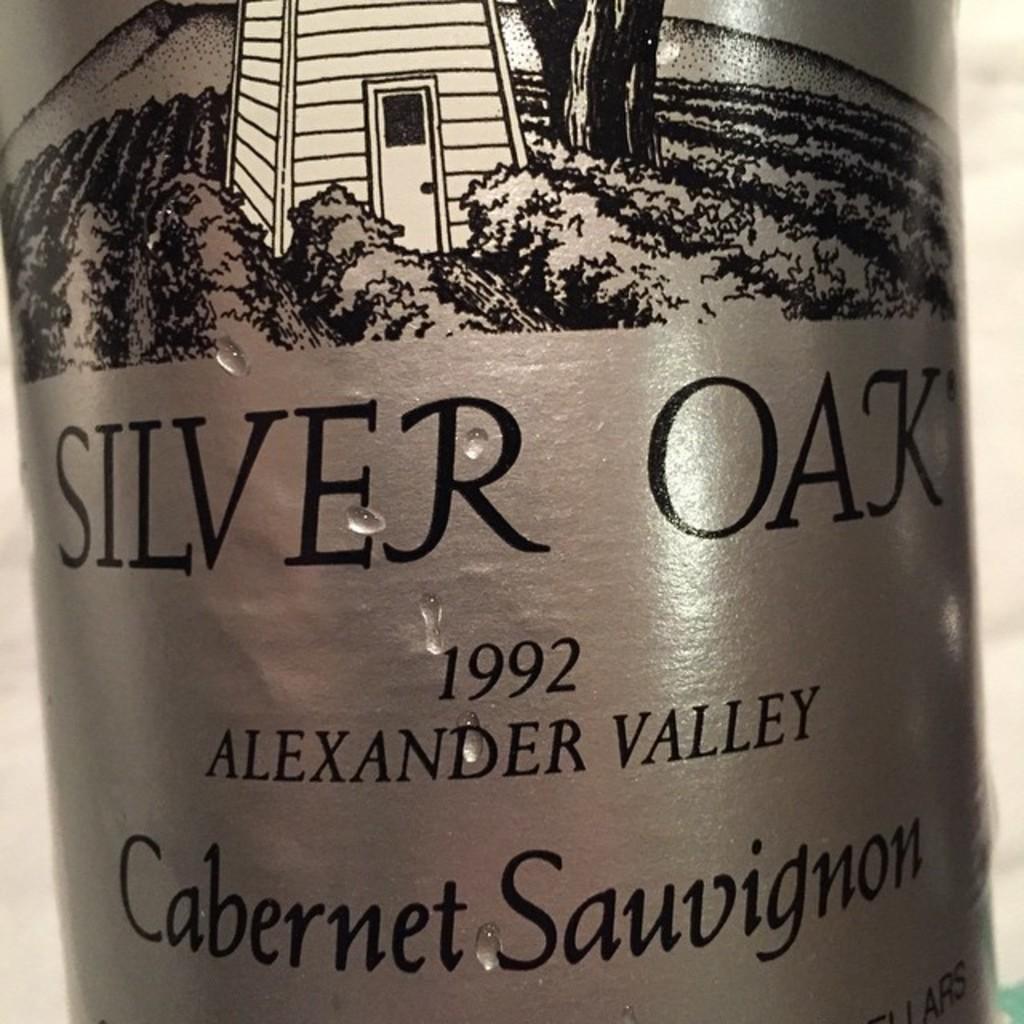What type of wine is silver oak?
Your response must be concise. Cabernet sauvignon. 